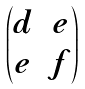Convert formula to latex. <formula><loc_0><loc_0><loc_500><loc_500>\begin{pmatrix} d & e \\ e & f \end{pmatrix}</formula> 